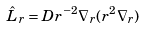<formula> <loc_0><loc_0><loc_500><loc_500>\hat { L } _ { r } = D r ^ { - 2 } \nabla _ { r } ( r ^ { 2 } \nabla _ { r } )</formula> 